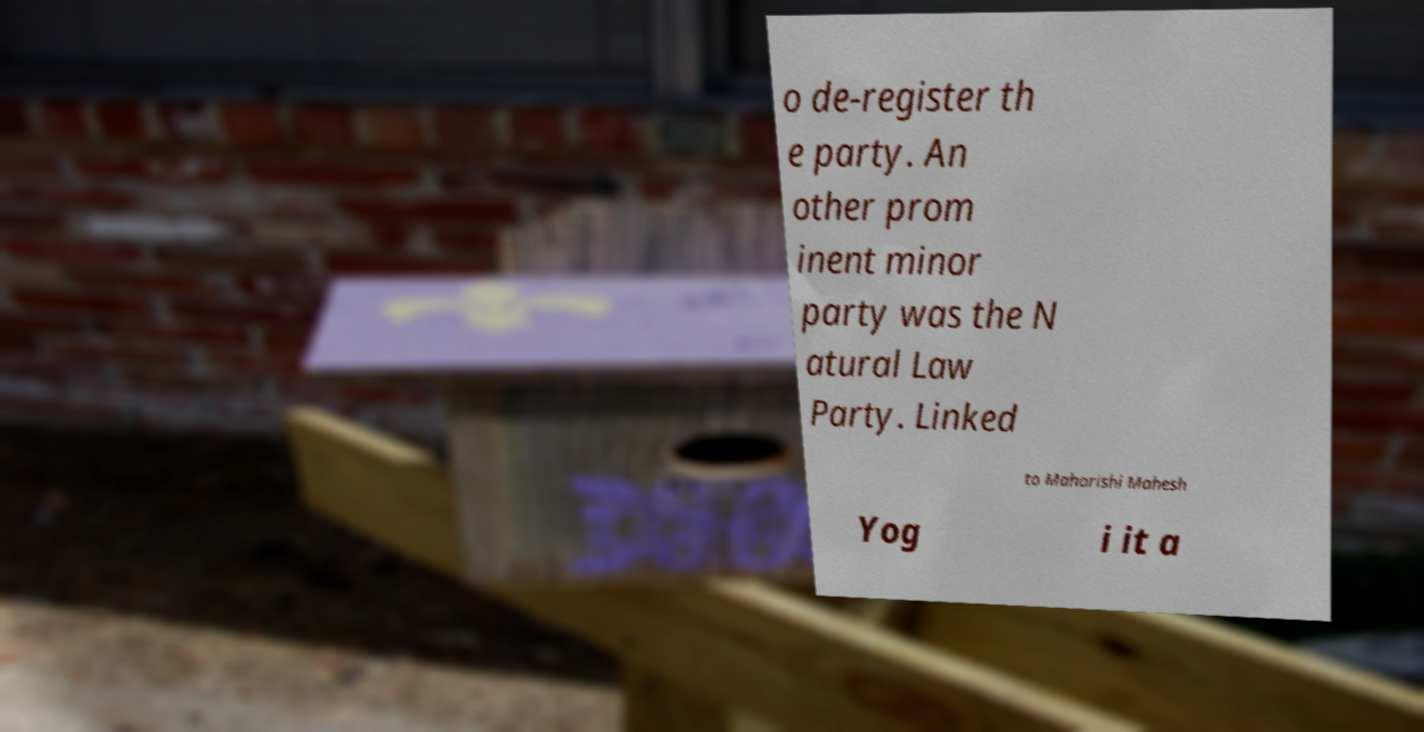I need the written content from this picture converted into text. Can you do that? o de-register th e party. An other prom inent minor party was the N atural Law Party. Linked to Maharishi Mahesh Yog i it a 